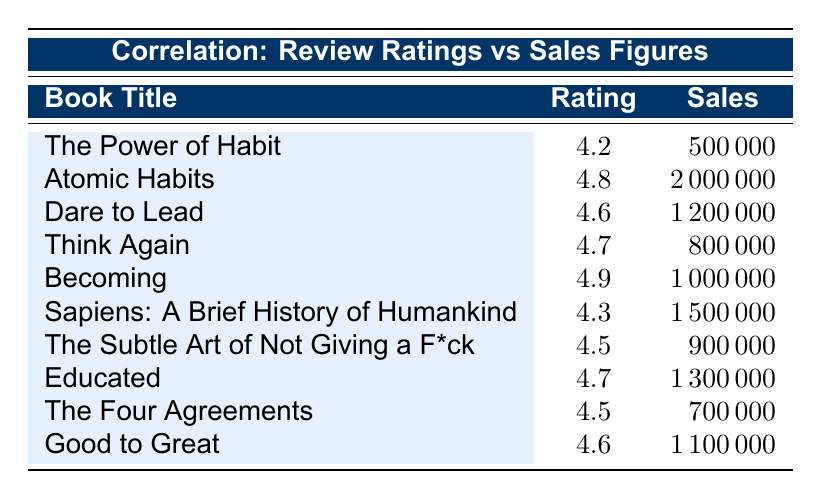What is the review rating of "Educated"? The table shows that the review rating for "Educated" is listed under the corresponding row for that book. It provides a clear value of 4.7.
Answer: 4.7 Which book has the highest sales figures and what are those figures? By looking at the sales figures column, "Atomic Habits" has the highest figure at 2000000, making it the book with the highest sales.
Answer: 2000000 What is the average review rating of the books listed in the table? To calculate the average, sum all the review ratings: (4.2 + 4.8 + 4.6 + 4.7 + 4.9 + 4.3 + 4.5 + 4.7 + 4.5 + 4.6) = 46.3. Then divide by the number of books, which is 10: 46.3 / 10 = 4.63.
Answer: 4.63 Is it true that all books with a review rating above 4.5 have sales figures exceeding 900000? Checking each book with a rating above 4.5, we find "The Subtle Art of Not Giving a F*ck," which has a rating of 4.5 but only 900000 in sales. So, not all of them exceed 900000.
Answer: No What is the difference in sales figures between "Becoming" and "The Four Agreements"? "Becoming" has sales of 1000000 while "The Four Agreements" has sales of 700000. Calculating the difference: 1000000 - 700000 = 300000.
Answer: 300000 How many books have sales figures greater than 1 million? Inspecting the sales figures, the books "Atomic Habits," "Dare to Lead," "Sapiens: A Brief History of Humankind," "Educated," and "Good to Great" have sales figures greater than 1 million. There are a total of 5 such books.
Answer: 5 Which author wrote the book with the lowest review rating? Looking at the review ratings, "The Power of Habit" has the lowest rating of 4.2. Thus, Charles Duhigg is the author of the book with the lowest rating.
Answer: Charles Duhigg What is the total sales figure for the books with a review rating of 4.6 or higher? The books with a rating of 4.6 or higher are "Atomic Habits," "Dare to Lead," "Think Again," "Becoming," "Educated," "Good to Great," "The Subtle Art of Not Giving a F*ck." Their sales figures are 2000000 + 1200000 + 800000 + 1000000 + 1300000 + 1100000 + 900000 = 10500000.
Answer: 10500000 